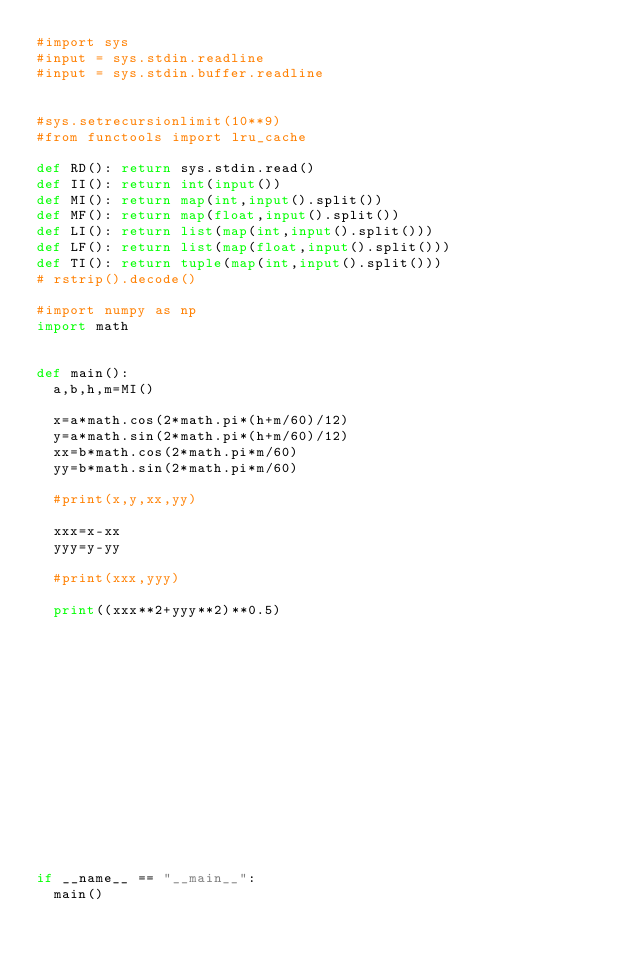<code> <loc_0><loc_0><loc_500><loc_500><_Python_>#import sys
#input = sys.stdin.readline
#input = sys.stdin.buffer.readline


#sys.setrecursionlimit(10**9)
#from functools import lru_cache

def RD(): return sys.stdin.read()
def II(): return int(input())
def MI(): return map(int,input().split())
def MF(): return map(float,input().split())
def LI(): return list(map(int,input().split()))
def LF(): return list(map(float,input().split()))
def TI(): return tuple(map(int,input().split()))
# rstrip().decode()

#import numpy as np
import math


def main():
	a,b,h,m=MI()

	x=a*math.cos(2*math.pi*(h+m/60)/12)
	y=a*math.sin(2*math.pi*(h+m/60)/12)
	xx=b*math.cos(2*math.pi*m/60)
	yy=b*math.sin(2*math.pi*m/60)

	#print(x,y,xx,yy)

	xxx=x-xx
	yyy=y-yy

	#print(xxx,yyy)

	print((xxx**2+yyy**2)**0.5)
















if __name__ == "__main__":
	main()
</code> 